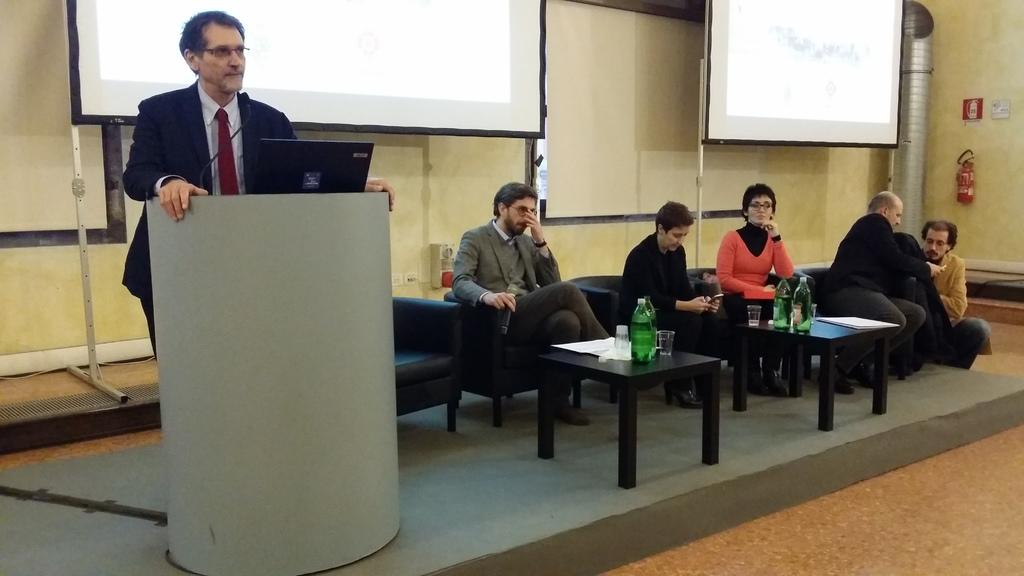What is the man in the image doing? There is a man standing in the image. What object can be seen on the podium in the image? A laptop is present on the podium in the image. What are the people in the image doing? There are people sitting on chairs in the image. Can you tell me how many feathers are on the actor's hat in the image? There is no actor or hat with feathers present in the image. What reason does the man standing have for being in the image? The provided facts do not give any information about the man's reason for being in the image. 